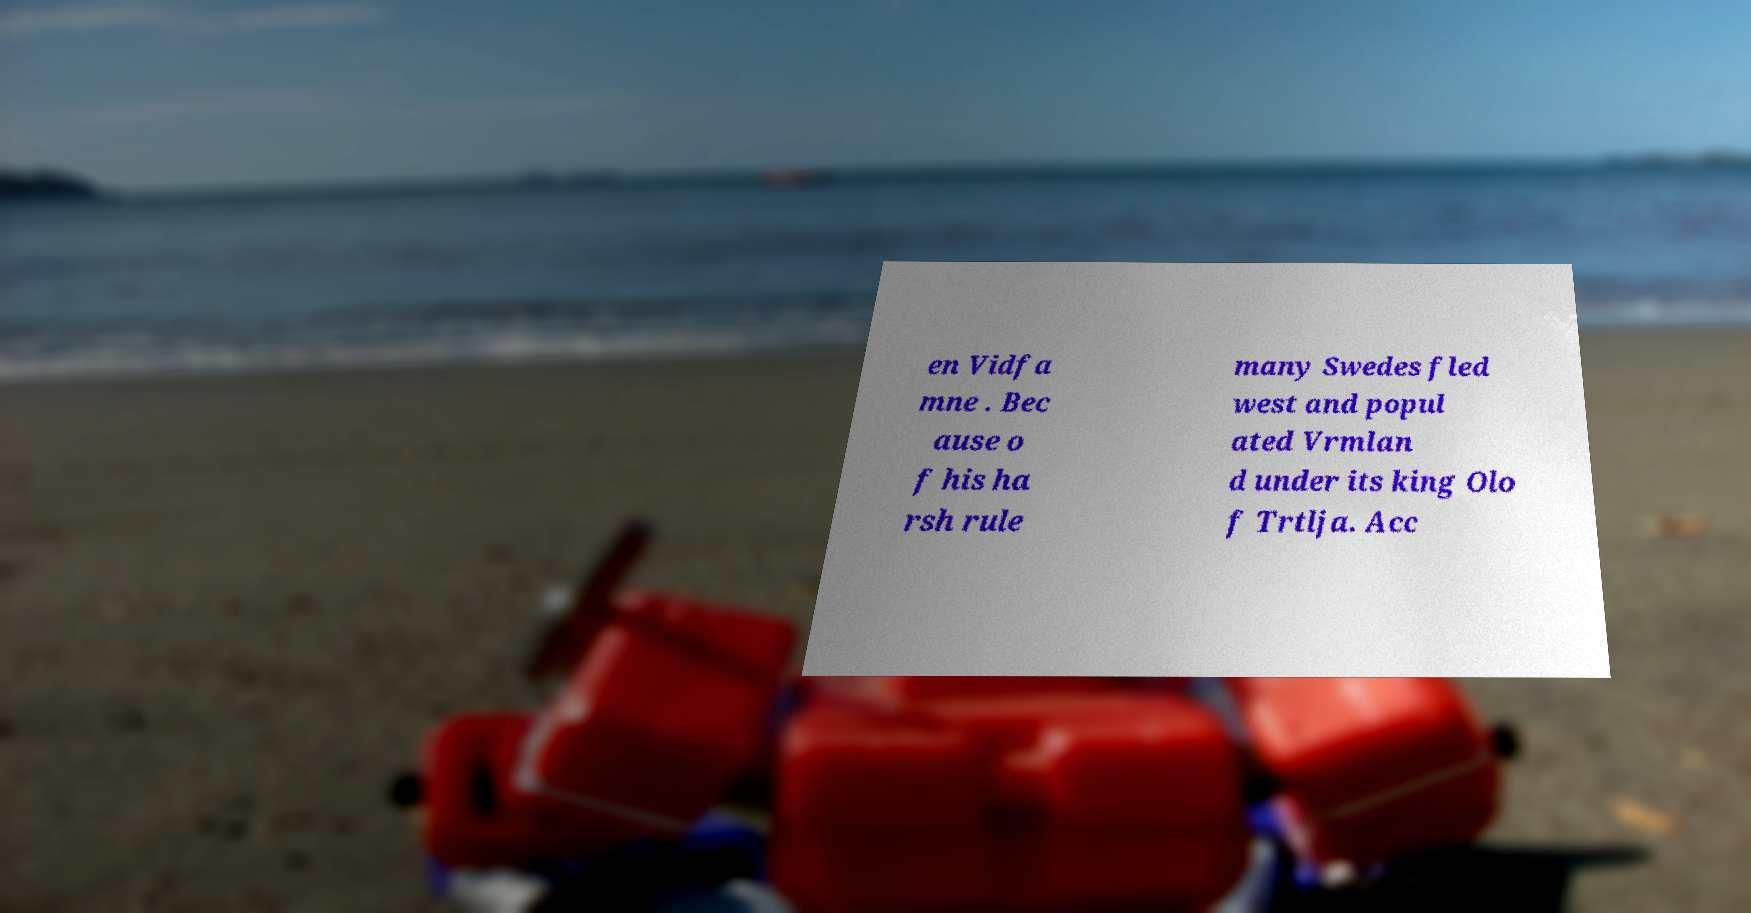Please identify and transcribe the text found in this image. en Vidfa mne . Bec ause o f his ha rsh rule many Swedes fled west and popul ated Vrmlan d under its king Olo f Trtlja. Acc 